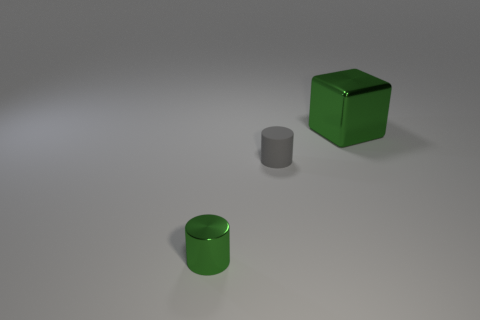What number of other things are the same color as the matte cylinder?
Ensure brevity in your answer.  0. Is there anything else that has the same size as the green metallic cube?
Your answer should be very brief. No. What size is the green cylinder that is made of the same material as the large green object?
Your answer should be compact. Small. What material is the small green object that is the same shape as the gray matte object?
Your answer should be compact. Metal. What number of objects are either large blocks behind the small green shiny thing or green metal objects behind the gray object?
Provide a succinct answer. 1. Does the small gray rubber object have the same shape as the green metallic thing behind the tiny shiny cylinder?
Ensure brevity in your answer.  No. The green thing in front of the green thing right of the cylinder right of the tiny shiny cylinder is what shape?
Keep it short and to the point. Cylinder. What number of other things are there of the same material as the large object
Your answer should be compact. 1. How many objects are objects that are in front of the small rubber object or brown blocks?
Your answer should be very brief. 1. The green thing behind the metallic thing in front of the green block is what shape?
Offer a very short reply. Cube. 